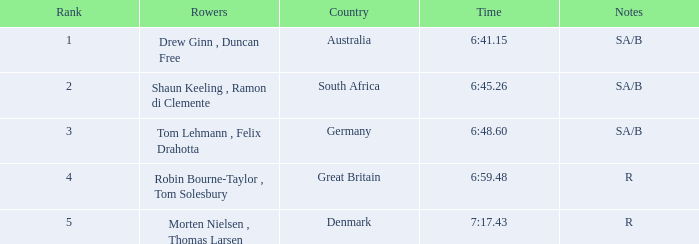What was the time for the rowers representing great britain? 6:59.48. 